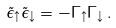<formula> <loc_0><loc_0><loc_500><loc_500>\tilde { \epsilon } _ { \uparrow } \tilde { \epsilon } _ { \downarrow } = - \Gamma _ { \uparrow } \Gamma _ { \downarrow } \, .</formula> 